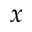Convert formula to latex. <formula><loc_0><loc_0><loc_500><loc_500>x</formula> 